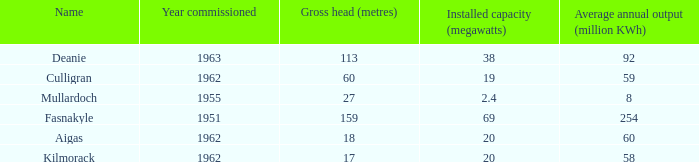What is the Average annual output for Culligran power station with an Installed capacity less than 19? None. 